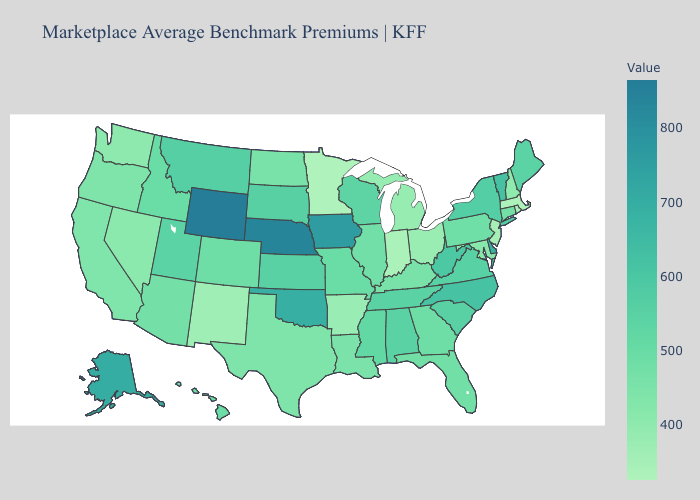Does Kentucky have the highest value in the South?
Be succinct. No. Which states have the lowest value in the South?
Write a very short answer. Arkansas. Does Pennsylvania have a higher value than New Mexico?
Be succinct. Yes. Which states have the lowest value in the Northeast?
Keep it brief. Massachusetts. 